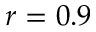<formula> <loc_0><loc_0><loc_500><loc_500>r = 0 . 9</formula> 